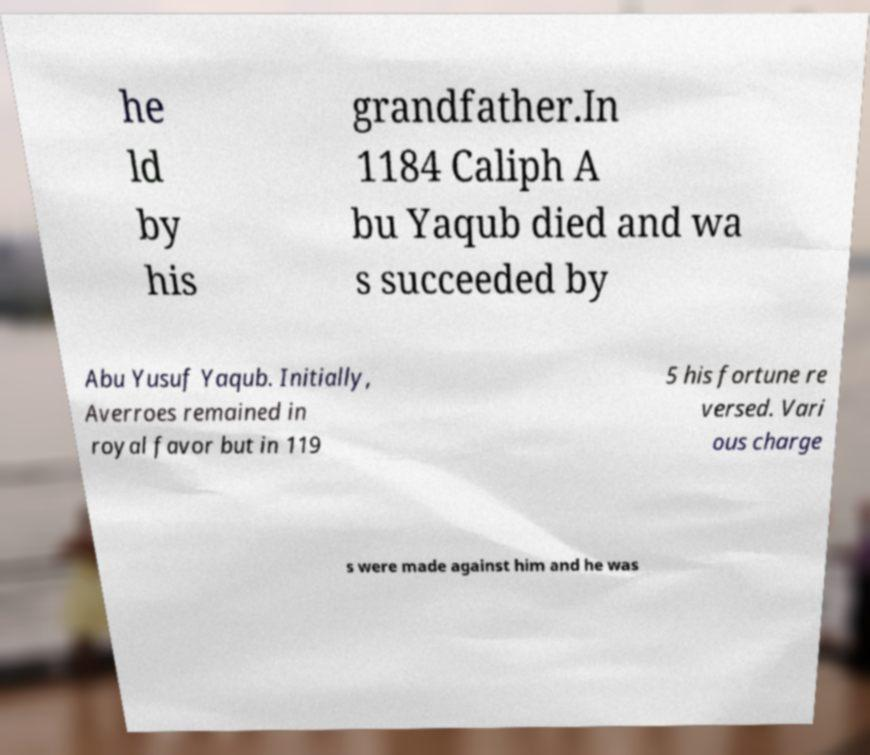Please identify and transcribe the text found in this image. he ld by his grandfather.In 1184 Caliph A bu Yaqub died and wa s succeeded by Abu Yusuf Yaqub. Initially, Averroes remained in royal favor but in 119 5 his fortune re versed. Vari ous charge s were made against him and he was 